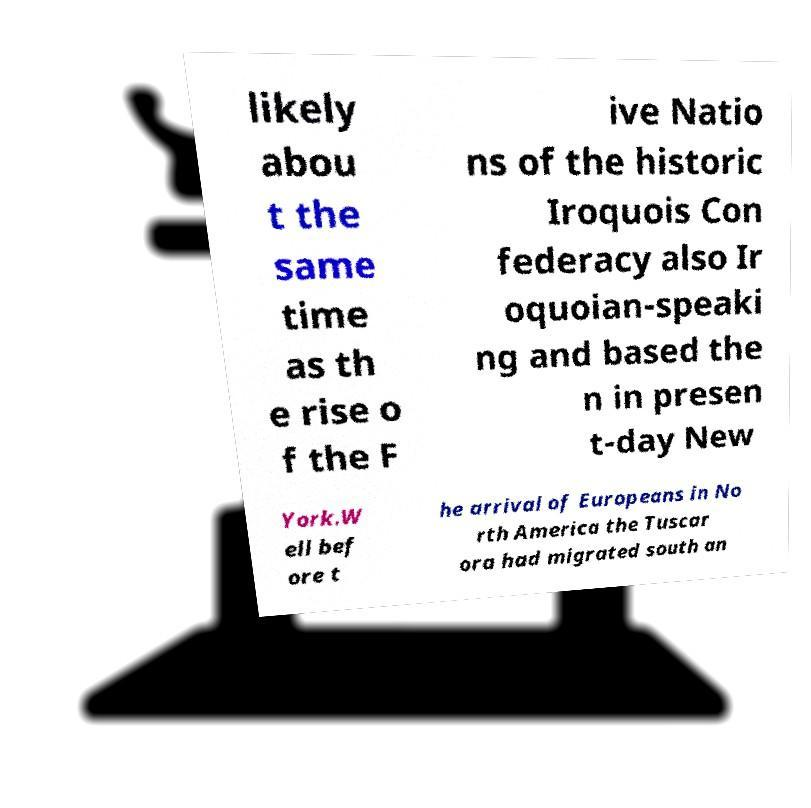I need the written content from this picture converted into text. Can you do that? likely abou t the same time as th e rise o f the F ive Natio ns of the historic Iroquois Con federacy also Ir oquoian-speaki ng and based the n in presen t-day New York.W ell bef ore t he arrival of Europeans in No rth America the Tuscar ora had migrated south an 